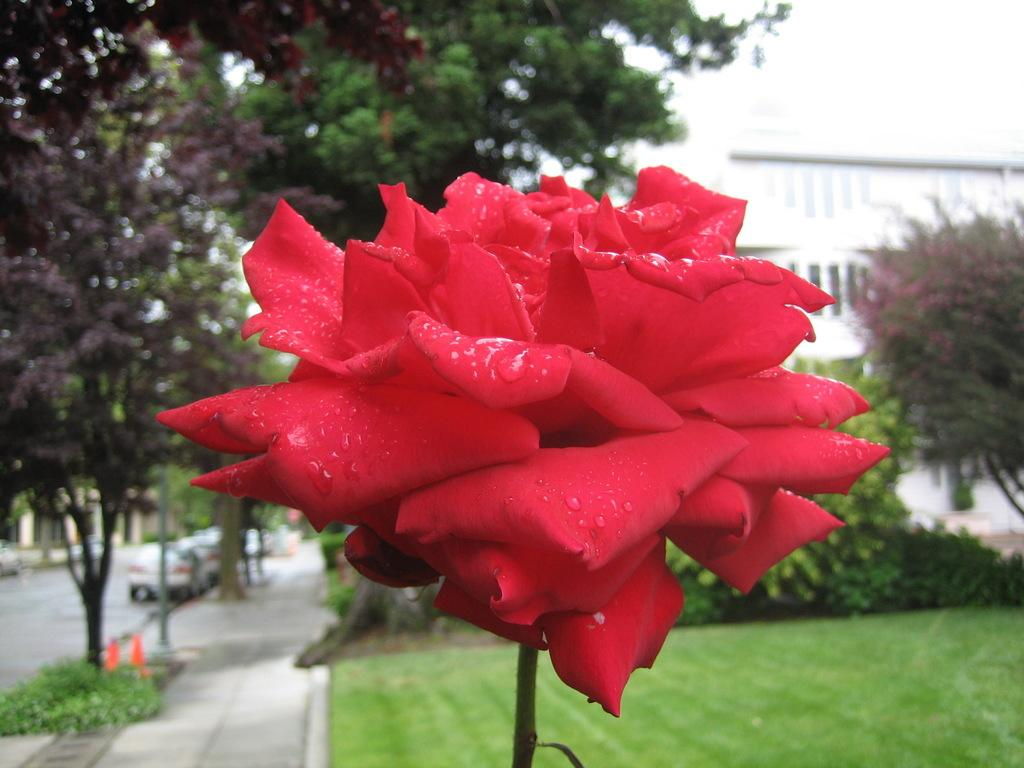What type of flower is visible in the image? There is a red flower with a stem in the image. What can be seen in the background of the image? There is grass, plants, trees, vehicles on the road, a pole, and a building in the background of the image. How many different types of vegetation can be seen in the background? There are three types of vegetation visible in the background: grass, plants, and trees. What is the opinion of the wren about the red flower in the image? There is no wren present in the image, so it is not possible to determine its opinion about the red flower. 